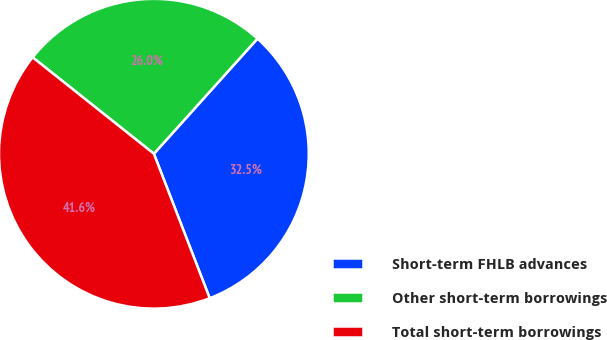Convert chart. <chart><loc_0><loc_0><loc_500><loc_500><pie_chart><fcel>Short-term FHLB advances<fcel>Other short-term borrowings<fcel>Total short-term borrowings<nl><fcel>32.47%<fcel>25.97%<fcel>41.56%<nl></chart> 